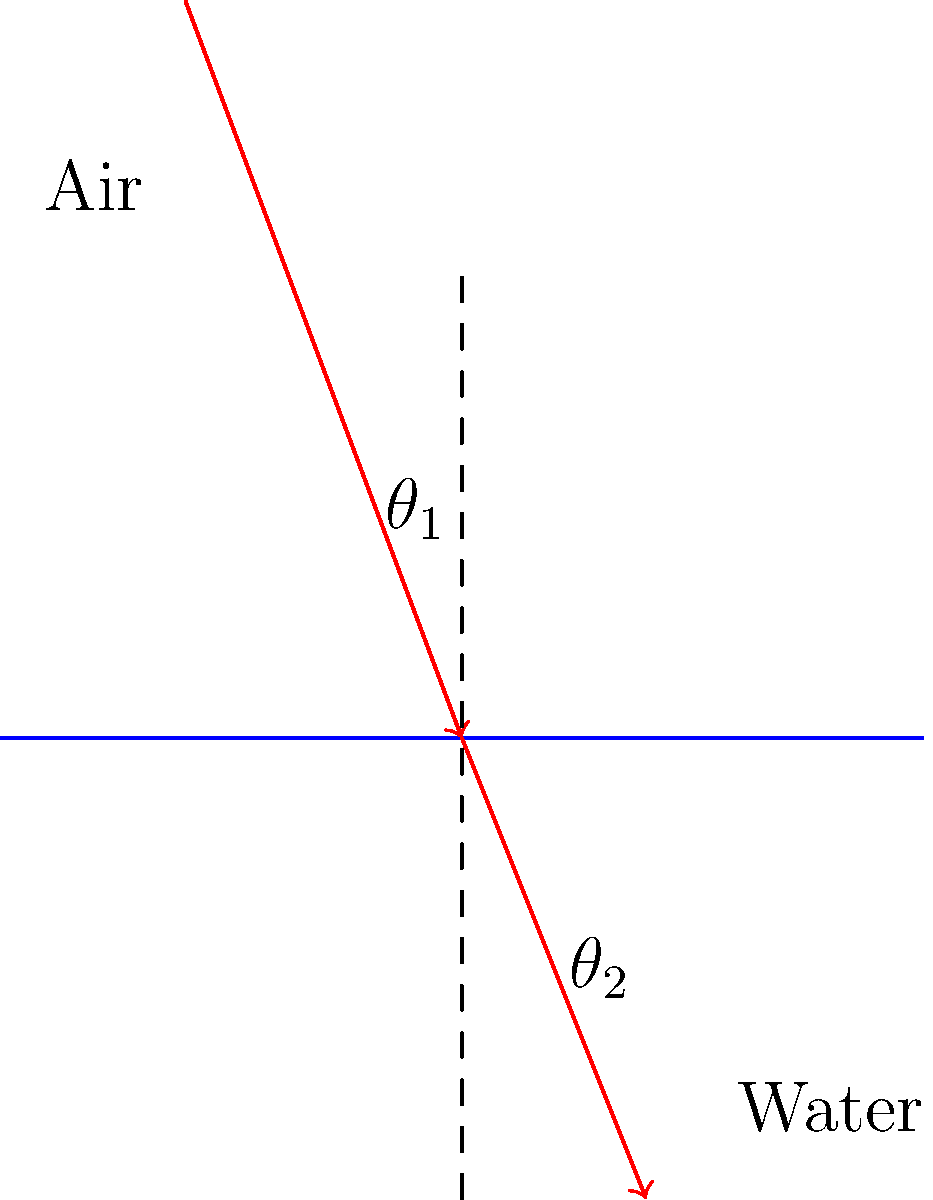In the crystal-clear waters surrounding Koh Phangan, light bends as it travels from air into water. If the angle of incidence ($\theta_1$) is 45°, and the refractive index of air is 1.00 while that of seawater is 1.33, what is the angle of refraction ($\theta_2$) to the nearest degree? To solve this problem, we'll use Snell's Law, which describes the relationship between the angles of incidence and refraction when light passes between two different media:

1) Snell's Law: $n_1 \sin(\theta_1) = n_2 \sin(\theta_2)$

Where:
$n_1$ = refractive index of air = 1.00
$n_2$ = refractive index of seawater = 1.33
$\theta_1$ = angle of incidence = 45°
$\theta_2$ = angle of refraction (unknown)

2) Rearrange Snell's Law to solve for $\sin(\theta_2)$:

   $\sin(\theta_2) = \frac{n_1 \sin(\theta_1)}{n_2}$

3) Substitute the known values:

   $\sin(\theta_2) = \frac{1.00 \sin(45°)}{1.33}$

4) Calculate $\sin(45°)$:

   $\sin(45°) = \frac{\sqrt{2}}{2} \approx 0.7071$

5) Substitute this value:

   $\sin(\theta_2) = \frac{1.00 * 0.7071}{1.33} \approx 0.5317$

6) To find $\theta_2$, we need to take the inverse sine (arcsin) of this value:

   $\theta_2 = \arcsin(0.5317) \approx 32.04°$

7) Rounding to the nearest degree:

   $\theta_2 \approx 32°$
Answer: 32° 